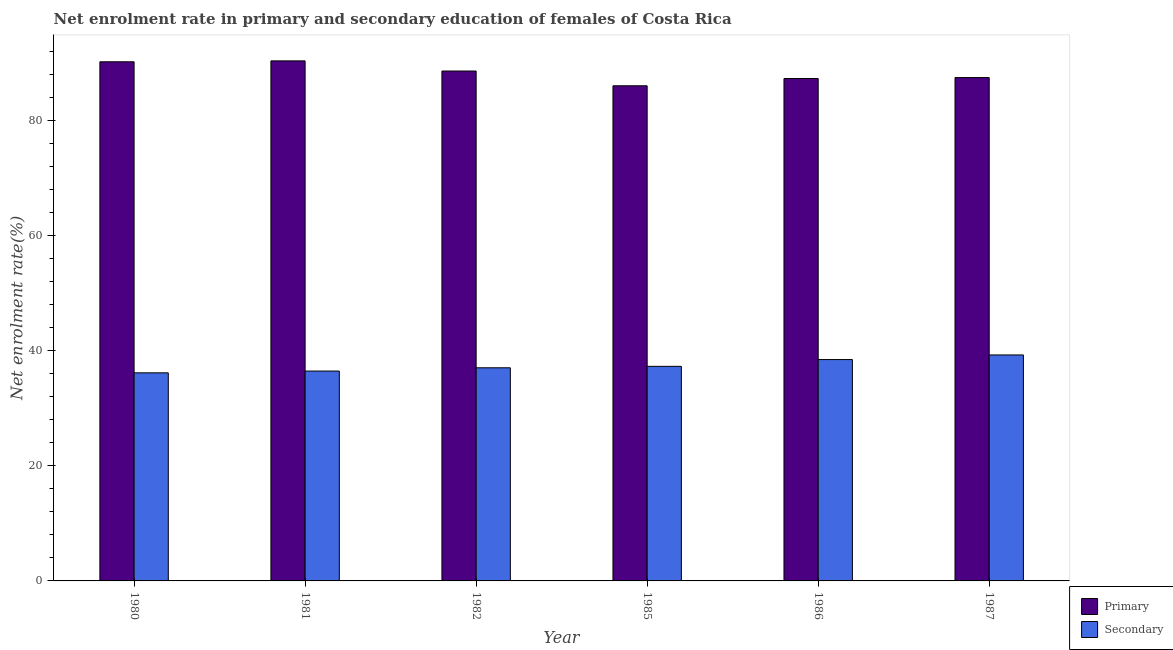How many different coloured bars are there?
Your response must be concise. 2. Are the number of bars on each tick of the X-axis equal?
Give a very brief answer. Yes. How many bars are there on the 4th tick from the right?
Provide a succinct answer. 2. In how many cases, is the number of bars for a given year not equal to the number of legend labels?
Your answer should be very brief. 0. What is the enrollment rate in secondary education in 1980?
Give a very brief answer. 36.18. Across all years, what is the maximum enrollment rate in primary education?
Offer a very short reply. 90.42. Across all years, what is the minimum enrollment rate in secondary education?
Your response must be concise. 36.18. In which year was the enrollment rate in secondary education maximum?
Offer a very short reply. 1987. In which year was the enrollment rate in secondary education minimum?
Offer a terse response. 1980. What is the total enrollment rate in primary education in the graph?
Offer a very short reply. 530.28. What is the difference between the enrollment rate in secondary education in 1981 and that in 1987?
Offer a very short reply. -2.8. What is the difference between the enrollment rate in primary education in 1981 and the enrollment rate in secondary education in 1985?
Make the answer very short. 4.33. What is the average enrollment rate in primary education per year?
Your answer should be very brief. 88.38. What is the ratio of the enrollment rate in primary education in 1980 to that in 1985?
Offer a very short reply. 1.05. Is the difference between the enrollment rate in primary education in 1981 and 1987 greater than the difference between the enrollment rate in secondary education in 1981 and 1987?
Keep it short and to the point. No. What is the difference between the highest and the second highest enrollment rate in secondary education?
Provide a short and direct response. 0.8. What is the difference between the highest and the lowest enrollment rate in secondary education?
Give a very brief answer. 3.11. What does the 1st bar from the left in 1982 represents?
Give a very brief answer. Primary. What does the 1st bar from the right in 1981 represents?
Provide a short and direct response. Secondary. How many bars are there?
Keep it short and to the point. 12. Are all the bars in the graph horizontal?
Ensure brevity in your answer.  No. Does the graph contain grids?
Your answer should be compact. No. What is the title of the graph?
Ensure brevity in your answer.  Net enrolment rate in primary and secondary education of females of Costa Rica. Does "Death rate" appear as one of the legend labels in the graph?
Offer a terse response. No. What is the label or title of the Y-axis?
Your answer should be very brief. Net enrolment rate(%). What is the Net enrolment rate(%) of Primary in 1980?
Offer a terse response. 90.26. What is the Net enrolment rate(%) of Secondary in 1980?
Provide a succinct answer. 36.18. What is the Net enrolment rate(%) in Primary in 1981?
Ensure brevity in your answer.  90.42. What is the Net enrolment rate(%) of Secondary in 1981?
Your response must be concise. 36.49. What is the Net enrolment rate(%) of Primary in 1982?
Provide a short and direct response. 88.65. What is the Net enrolment rate(%) of Secondary in 1982?
Make the answer very short. 37.06. What is the Net enrolment rate(%) of Primary in 1985?
Your answer should be compact. 86.09. What is the Net enrolment rate(%) of Secondary in 1985?
Give a very brief answer. 37.31. What is the Net enrolment rate(%) in Primary in 1986?
Provide a succinct answer. 87.35. What is the Net enrolment rate(%) of Secondary in 1986?
Give a very brief answer. 38.49. What is the Net enrolment rate(%) of Primary in 1987?
Provide a succinct answer. 87.51. What is the Net enrolment rate(%) in Secondary in 1987?
Your response must be concise. 39.29. Across all years, what is the maximum Net enrolment rate(%) of Primary?
Your answer should be compact. 90.42. Across all years, what is the maximum Net enrolment rate(%) of Secondary?
Keep it short and to the point. 39.29. Across all years, what is the minimum Net enrolment rate(%) of Primary?
Offer a very short reply. 86.09. Across all years, what is the minimum Net enrolment rate(%) of Secondary?
Keep it short and to the point. 36.18. What is the total Net enrolment rate(%) in Primary in the graph?
Offer a very short reply. 530.28. What is the total Net enrolment rate(%) of Secondary in the graph?
Offer a very short reply. 224.81. What is the difference between the Net enrolment rate(%) in Primary in 1980 and that in 1981?
Give a very brief answer. -0.16. What is the difference between the Net enrolment rate(%) of Secondary in 1980 and that in 1981?
Provide a succinct answer. -0.31. What is the difference between the Net enrolment rate(%) in Primary in 1980 and that in 1982?
Make the answer very short. 1.61. What is the difference between the Net enrolment rate(%) of Secondary in 1980 and that in 1982?
Keep it short and to the point. -0.88. What is the difference between the Net enrolment rate(%) in Primary in 1980 and that in 1985?
Offer a terse response. 4.17. What is the difference between the Net enrolment rate(%) of Secondary in 1980 and that in 1985?
Keep it short and to the point. -1.13. What is the difference between the Net enrolment rate(%) of Primary in 1980 and that in 1986?
Your answer should be compact. 2.91. What is the difference between the Net enrolment rate(%) of Secondary in 1980 and that in 1986?
Your response must be concise. -2.31. What is the difference between the Net enrolment rate(%) of Primary in 1980 and that in 1987?
Make the answer very short. 2.74. What is the difference between the Net enrolment rate(%) in Secondary in 1980 and that in 1987?
Your answer should be compact. -3.11. What is the difference between the Net enrolment rate(%) of Primary in 1981 and that in 1982?
Offer a very short reply. 1.77. What is the difference between the Net enrolment rate(%) in Secondary in 1981 and that in 1982?
Keep it short and to the point. -0.57. What is the difference between the Net enrolment rate(%) of Primary in 1981 and that in 1985?
Offer a very short reply. 4.33. What is the difference between the Net enrolment rate(%) in Secondary in 1981 and that in 1985?
Ensure brevity in your answer.  -0.82. What is the difference between the Net enrolment rate(%) in Primary in 1981 and that in 1986?
Your response must be concise. 3.07. What is the difference between the Net enrolment rate(%) of Secondary in 1981 and that in 1986?
Keep it short and to the point. -2. What is the difference between the Net enrolment rate(%) in Primary in 1981 and that in 1987?
Offer a terse response. 2.9. What is the difference between the Net enrolment rate(%) in Secondary in 1981 and that in 1987?
Provide a short and direct response. -2.8. What is the difference between the Net enrolment rate(%) in Primary in 1982 and that in 1985?
Provide a short and direct response. 2.57. What is the difference between the Net enrolment rate(%) in Secondary in 1982 and that in 1985?
Offer a very short reply. -0.25. What is the difference between the Net enrolment rate(%) in Primary in 1982 and that in 1986?
Make the answer very short. 1.3. What is the difference between the Net enrolment rate(%) of Secondary in 1982 and that in 1986?
Provide a succinct answer. -1.43. What is the difference between the Net enrolment rate(%) in Primary in 1982 and that in 1987?
Give a very brief answer. 1.14. What is the difference between the Net enrolment rate(%) of Secondary in 1982 and that in 1987?
Ensure brevity in your answer.  -2.23. What is the difference between the Net enrolment rate(%) in Primary in 1985 and that in 1986?
Ensure brevity in your answer.  -1.26. What is the difference between the Net enrolment rate(%) of Secondary in 1985 and that in 1986?
Provide a short and direct response. -1.18. What is the difference between the Net enrolment rate(%) of Primary in 1985 and that in 1987?
Your answer should be very brief. -1.43. What is the difference between the Net enrolment rate(%) of Secondary in 1985 and that in 1987?
Offer a very short reply. -1.98. What is the difference between the Net enrolment rate(%) in Primary in 1986 and that in 1987?
Ensure brevity in your answer.  -0.16. What is the difference between the Net enrolment rate(%) of Secondary in 1986 and that in 1987?
Offer a very short reply. -0.8. What is the difference between the Net enrolment rate(%) in Primary in 1980 and the Net enrolment rate(%) in Secondary in 1981?
Provide a succinct answer. 53.77. What is the difference between the Net enrolment rate(%) in Primary in 1980 and the Net enrolment rate(%) in Secondary in 1982?
Provide a short and direct response. 53.2. What is the difference between the Net enrolment rate(%) in Primary in 1980 and the Net enrolment rate(%) in Secondary in 1985?
Offer a terse response. 52.95. What is the difference between the Net enrolment rate(%) of Primary in 1980 and the Net enrolment rate(%) of Secondary in 1986?
Your answer should be compact. 51.77. What is the difference between the Net enrolment rate(%) in Primary in 1980 and the Net enrolment rate(%) in Secondary in 1987?
Provide a short and direct response. 50.97. What is the difference between the Net enrolment rate(%) of Primary in 1981 and the Net enrolment rate(%) of Secondary in 1982?
Ensure brevity in your answer.  53.36. What is the difference between the Net enrolment rate(%) of Primary in 1981 and the Net enrolment rate(%) of Secondary in 1985?
Ensure brevity in your answer.  53.11. What is the difference between the Net enrolment rate(%) of Primary in 1981 and the Net enrolment rate(%) of Secondary in 1986?
Your response must be concise. 51.93. What is the difference between the Net enrolment rate(%) of Primary in 1981 and the Net enrolment rate(%) of Secondary in 1987?
Offer a very short reply. 51.13. What is the difference between the Net enrolment rate(%) in Primary in 1982 and the Net enrolment rate(%) in Secondary in 1985?
Ensure brevity in your answer.  51.35. What is the difference between the Net enrolment rate(%) in Primary in 1982 and the Net enrolment rate(%) in Secondary in 1986?
Ensure brevity in your answer.  50.16. What is the difference between the Net enrolment rate(%) of Primary in 1982 and the Net enrolment rate(%) of Secondary in 1987?
Make the answer very short. 49.36. What is the difference between the Net enrolment rate(%) of Primary in 1985 and the Net enrolment rate(%) of Secondary in 1986?
Offer a very short reply. 47.6. What is the difference between the Net enrolment rate(%) of Primary in 1985 and the Net enrolment rate(%) of Secondary in 1987?
Keep it short and to the point. 46.8. What is the difference between the Net enrolment rate(%) in Primary in 1986 and the Net enrolment rate(%) in Secondary in 1987?
Give a very brief answer. 48.06. What is the average Net enrolment rate(%) of Primary per year?
Provide a short and direct response. 88.38. What is the average Net enrolment rate(%) in Secondary per year?
Make the answer very short. 37.47. In the year 1980, what is the difference between the Net enrolment rate(%) of Primary and Net enrolment rate(%) of Secondary?
Keep it short and to the point. 54.08. In the year 1981, what is the difference between the Net enrolment rate(%) in Primary and Net enrolment rate(%) in Secondary?
Your answer should be compact. 53.93. In the year 1982, what is the difference between the Net enrolment rate(%) of Primary and Net enrolment rate(%) of Secondary?
Your answer should be compact. 51.6. In the year 1985, what is the difference between the Net enrolment rate(%) in Primary and Net enrolment rate(%) in Secondary?
Your answer should be compact. 48.78. In the year 1986, what is the difference between the Net enrolment rate(%) of Primary and Net enrolment rate(%) of Secondary?
Your answer should be compact. 48.86. In the year 1987, what is the difference between the Net enrolment rate(%) in Primary and Net enrolment rate(%) in Secondary?
Your answer should be very brief. 48.22. What is the ratio of the Net enrolment rate(%) in Secondary in 1980 to that in 1981?
Keep it short and to the point. 0.99. What is the ratio of the Net enrolment rate(%) in Primary in 1980 to that in 1982?
Offer a terse response. 1.02. What is the ratio of the Net enrolment rate(%) of Secondary in 1980 to that in 1982?
Offer a very short reply. 0.98. What is the ratio of the Net enrolment rate(%) of Primary in 1980 to that in 1985?
Keep it short and to the point. 1.05. What is the ratio of the Net enrolment rate(%) of Secondary in 1980 to that in 1985?
Your answer should be compact. 0.97. What is the ratio of the Net enrolment rate(%) in Primary in 1980 to that in 1987?
Your answer should be compact. 1.03. What is the ratio of the Net enrolment rate(%) in Secondary in 1980 to that in 1987?
Provide a short and direct response. 0.92. What is the ratio of the Net enrolment rate(%) in Primary in 1981 to that in 1982?
Your answer should be very brief. 1.02. What is the ratio of the Net enrolment rate(%) of Secondary in 1981 to that in 1982?
Give a very brief answer. 0.98. What is the ratio of the Net enrolment rate(%) of Primary in 1981 to that in 1985?
Provide a short and direct response. 1.05. What is the ratio of the Net enrolment rate(%) of Secondary in 1981 to that in 1985?
Keep it short and to the point. 0.98. What is the ratio of the Net enrolment rate(%) in Primary in 1981 to that in 1986?
Make the answer very short. 1.04. What is the ratio of the Net enrolment rate(%) in Secondary in 1981 to that in 1986?
Your answer should be very brief. 0.95. What is the ratio of the Net enrolment rate(%) of Primary in 1981 to that in 1987?
Give a very brief answer. 1.03. What is the ratio of the Net enrolment rate(%) of Secondary in 1981 to that in 1987?
Provide a succinct answer. 0.93. What is the ratio of the Net enrolment rate(%) in Primary in 1982 to that in 1985?
Your response must be concise. 1.03. What is the ratio of the Net enrolment rate(%) of Secondary in 1982 to that in 1985?
Provide a short and direct response. 0.99. What is the ratio of the Net enrolment rate(%) of Primary in 1982 to that in 1986?
Your answer should be very brief. 1.01. What is the ratio of the Net enrolment rate(%) of Secondary in 1982 to that in 1986?
Your response must be concise. 0.96. What is the ratio of the Net enrolment rate(%) in Secondary in 1982 to that in 1987?
Keep it short and to the point. 0.94. What is the ratio of the Net enrolment rate(%) of Primary in 1985 to that in 1986?
Your answer should be compact. 0.99. What is the ratio of the Net enrolment rate(%) of Secondary in 1985 to that in 1986?
Your answer should be very brief. 0.97. What is the ratio of the Net enrolment rate(%) in Primary in 1985 to that in 1987?
Your answer should be compact. 0.98. What is the ratio of the Net enrolment rate(%) of Secondary in 1985 to that in 1987?
Your response must be concise. 0.95. What is the ratio of the Net enrolment rate(%) of Secondary in 1986 to that in 1987?
Offer a very short reply. 0.98. What is the difference between the highest and the second highest Net enrolment rate(%) in Primary?
Offer a terse response. 0.16. What is the difference between the highest and the second highest Net enrolment rate(%) of Secondary?
Ensure brevity in your answer.  0.8. What is the difference between the highest and the lowest Net enrolment rate(%) of Primary?
Offer a very short reply. 4.33. What is the difference between the highest and the lowest Net enrolment rate(%) in Secondary?
Your answer should be very brief. 3.11. 